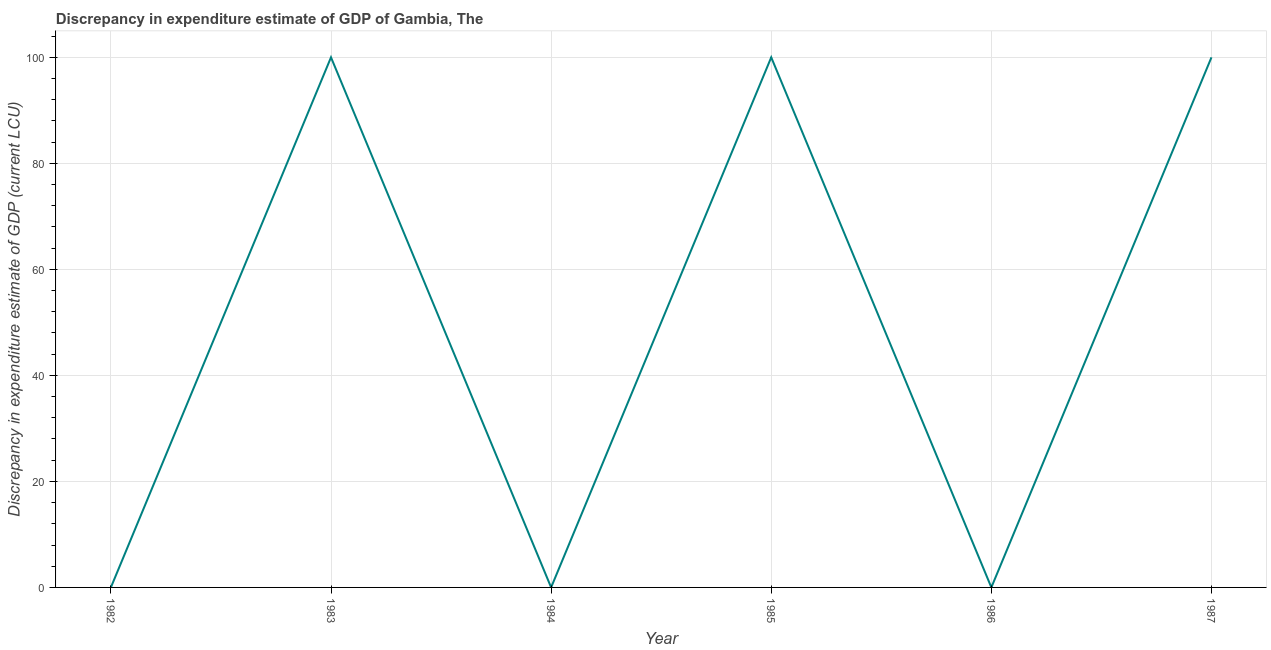What is the discrepancy in expenditure estimate of gdp in 1982?
Your answer should be compact. 0. Across all years, what is the maximum discrepancy in expenditure estimate of gdp?
Offer a terse response. 100. Across all years, what is the minimum discrepancy in expenditure estimate of gdp?
Your response must be concise. 0. What is the sum of the discrepancy in expenditure estimate of gdp?
Make the answer very short. 300. What is the difference between the discrepancy in expenditure estimate of gdp in 1983 and 1987?
Offer a terse response. -5.000001124244591e-8. What is the average discrepancy in expenditure estimate of gdp per year?
Give a very brief answer. 50. What is the median discrepancy in expenditure estimate of gdp?
Your answer should be compact. 50. In how many years, is the discrepancy in expenditure estimate of gdp greater than 24 LCU?
Provide a succinct answer. 3. What is the ratio of the discrepancy in expenditure estimate of gdp in 1984 to that in 1987?
Offer a very short reply. 4.999999996999999e-10. Is the discrepancy in expenditure estimate of gdp in 1985 less than that in 1987?
Make the answer very short. No. Is the difference between the discrepancy in expenditure estimate of gdp in 1983 and 1985 greater than the difference between any two years?
Make the answer very short. No. What is the difference between the highest and the second highest discrepancy in expenditure estimate of gdp?
Provide a succinct answer. 1.199999957179898e-7. What is the difference between the highest and the lowest discrepancy in expenditure estimate of gdp?
Ensure brevity in your answer.  100. How many years are there in the graph?
Provide a succinct answer. 6. Are the values on the major ticks of Y-axis written in scientific E-notation?
Provide a succinct answer. No. Does the graph contain any zero values?
Offer a very short reply. Yes. What is the title of the graph?
Your answer should be very brief. Discrepancy in expenditure estimate of GDP of Gambia, The. What is the label or title of the Y-axis?
Your response must be concise. Discrepancy in expenditure estimate of GDP (current LCU). What is the Discrepancy in expenditure estimate of GDP (current LCU) of 1983?
Offer a terse response. 100. What is the Discrepancy in expenditure estimate of GDP (current LCU) in 1984?
Ensure brevity in your answer.  5e-8. What is the Discrepancy in expenditure estimate of GDP (current LCU) in 1985?
Your answer should be very brief. 100. What is the Discrepancy in expenditure estimate of GDP (current LCU) of 1986?
Offer a terse response. 0. What is the Discrepancy in expenditure estimate of GDP (current LCU) in 1987?
Offer a very short reply. 100. What is the difference between the Discrepancy in expenditure estimate of GDP (current LCU) in 1983 and 1984?
Offer a very short reply. 100. What is the difference between the Discrepancy in expenditure estimate of GDP (current LCU) in 1983 and 1985?
Offer a very short reply. -0. What is the difference between the Discrepancy in expenditure estimate of GDP (current LCU) in 1983 and 1987?
Your answer should be compact. -0. What is the difference between the Discrepancy in expenditure estimate of GDP (current LCU) in 1984 and 1985?
Keep it short and to the point. -100. What is the difference between the Discrepancy in expenditure estimate of GDP (current LCU) in 1984 and 1987?
Give a very brief answer. -100. What is the difference between the Discrepancy in expenditure estimate of GDP (current LCU) in 1985 and 1987?
Ensure brevity in your answer.  0. What is the ratio of the Discrepancy in expenditure estimate of GDP (current LCU) in 1983 to that in 1984?
Keep it short and to the point. 2.00e+09. 